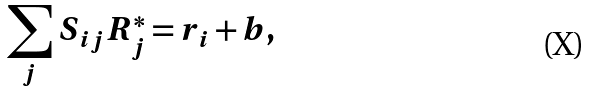Convert formula to latex. <formula><loc_0><loc_0><loc_500><loc_500>\sum _ { j } S _ { i j } R _ { j } ^ { * } = r _ { i } + b ,</formula> 